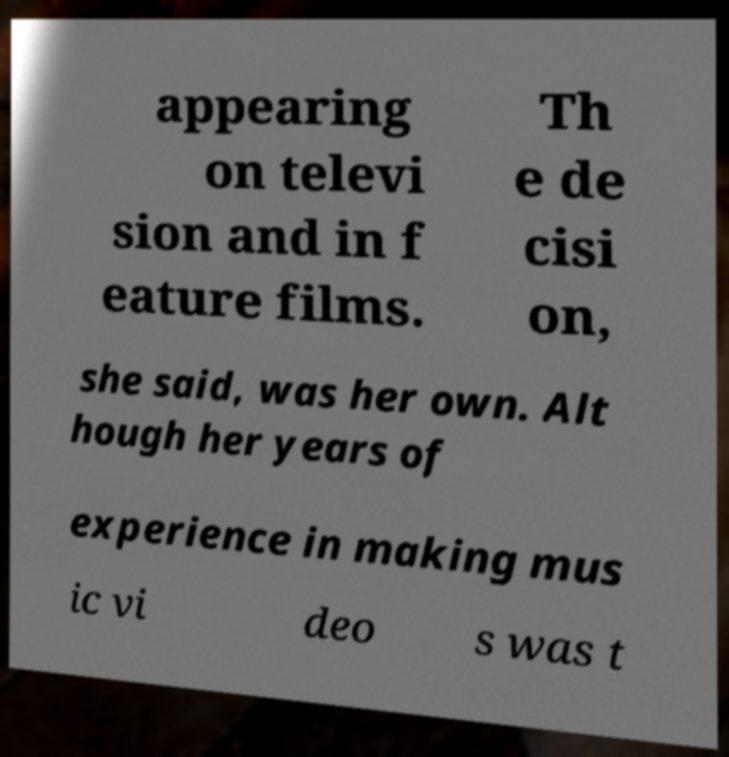What messages or text are displayed in this image? I need them in a readable, typed format. appearing on televi sion and in f eature films. Th e de cisi on, she said, was her own. Alt hough her years of experience in making mus ic vi deo s was t 